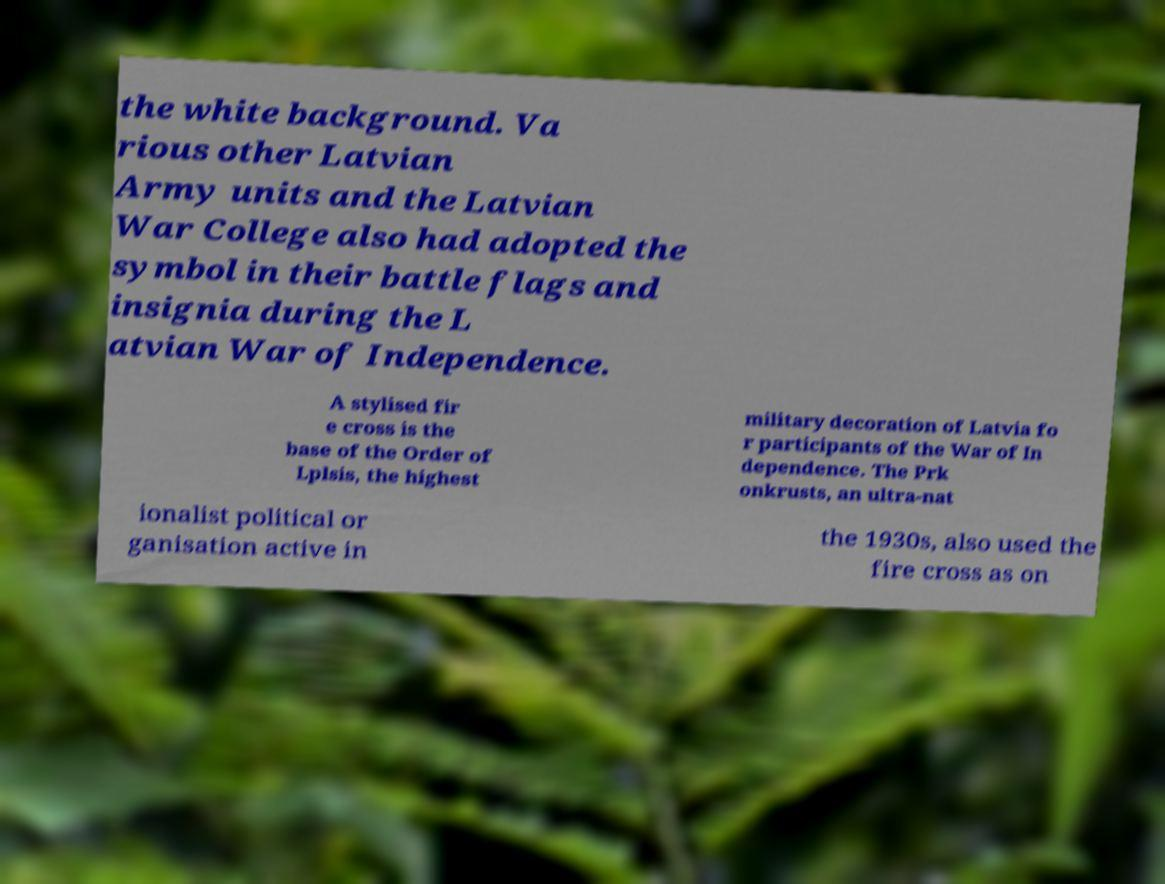Please read and relay the text visible in this image. What does it say? the white background. Va rious other Latvian Army units and the Latvian War College also had adopted the symbol in their battle flags and insignia during the L atvian War of Independence. A stylised fir e cross is the base of the Order of Lplsis, the highest military decoration of Latvia fo r participants of the War of In dependence. The Prk onkrusts, an ultra-nat ionalist political or ganisation active in the 1930s, also used the fire cross as on 